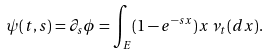Convert formula to latex. <formula><loc_0><loc_0><loc_500><loc_500>\psi ( t , s ) = \partial _ { s } \phi = \int _ { E } ( 1 - e ^ { - s x } ) x \, \nu _ { t } ( d x ) .</formula> 